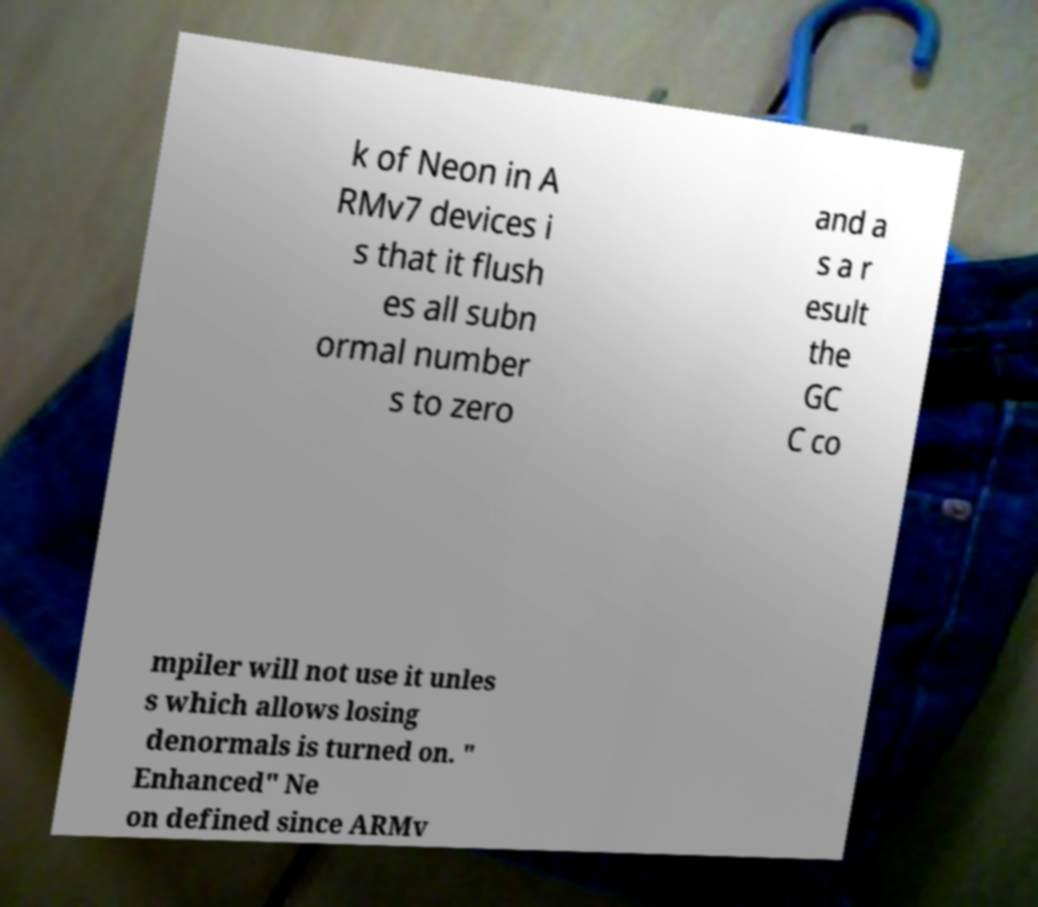Could you assist in decoding the text presented in this image and type it out clearly? k of Neon in A RMv7 devices i s that it flush es all subn ormal number s to zero and a s a r esult the GC C co mpiler will not use it unles s which allows losing denormals is turned on. " Enhanced" Ne on defined since ARMv 